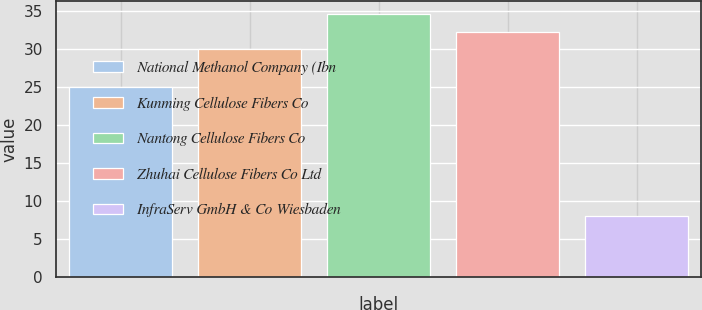<chart> <loc_0><loc_0><loc_500><loc_500><bar_chart><fcel>National Methanol Company (Ibn<fcel>Kunming Cellulose Fibers Co<fcel>Nantong Cellulose Fibers Co<fcel>Zhuhai Cellulose Fibers Co Ltd<fcel>InfraServ GmbH & Co Wiesbaden<nl><fcel>25<fcel>30<fcel>34.6<fcel>32.3<fcel>8<nl></chart> 